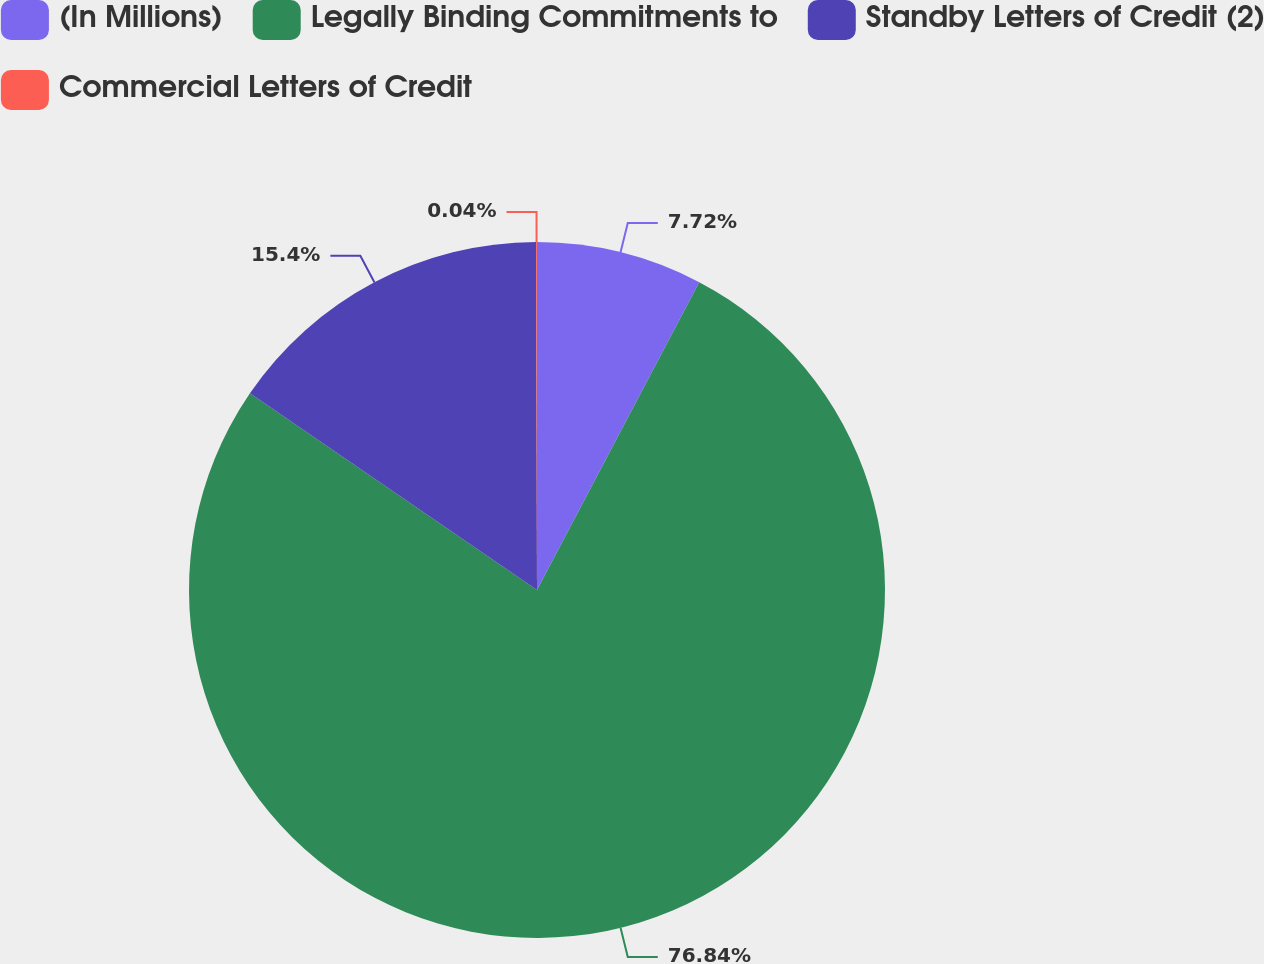<chart> <loc_0><loc_0><loc_500><loc_500><pie_chart><fcel>(In Millions)<fcel>Legally Binding Commitments to<fcel>Standby Letters of Credit (2)<fcel>Commercial Letters of Credit<nl><fcel>7.72%<fcel>76.85%<fcel>15.4%<fcel>0.04%<nl></chart> 